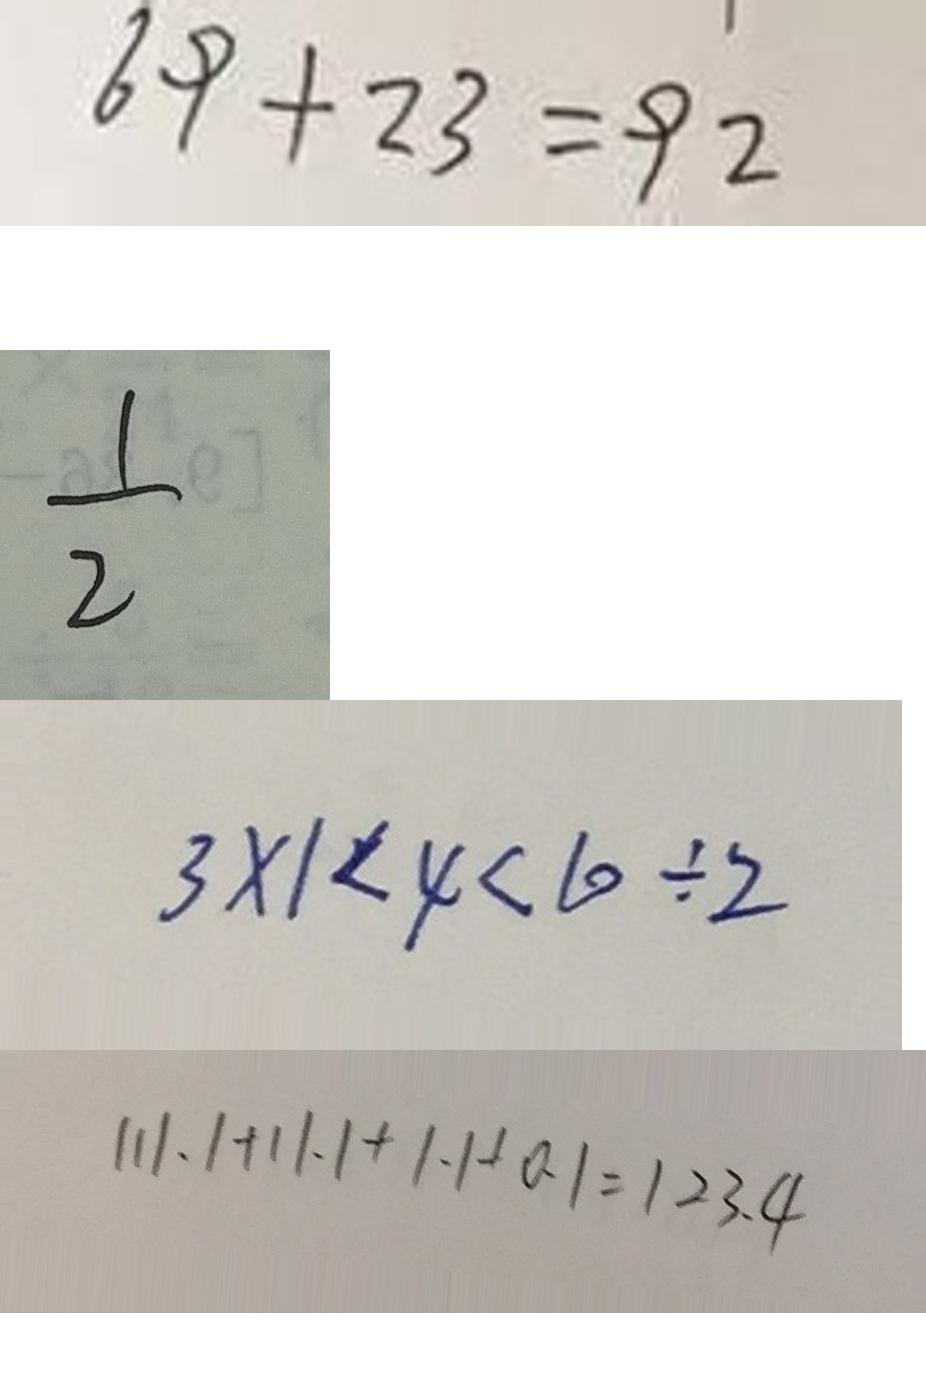Convert formula to latex. <formula><loc_0><loc_0><loc_500><loc_500>6 9 + 2 3 = 9 2 
 \frac { 1 } { 2 } 
 3 \times 1 < 4 < 1 0 \div 2 
 1 1 1 . 1 + 1 1 . 1 + 1 . 1 + 0 . 1 = 1 2 3 . 4</formula> 